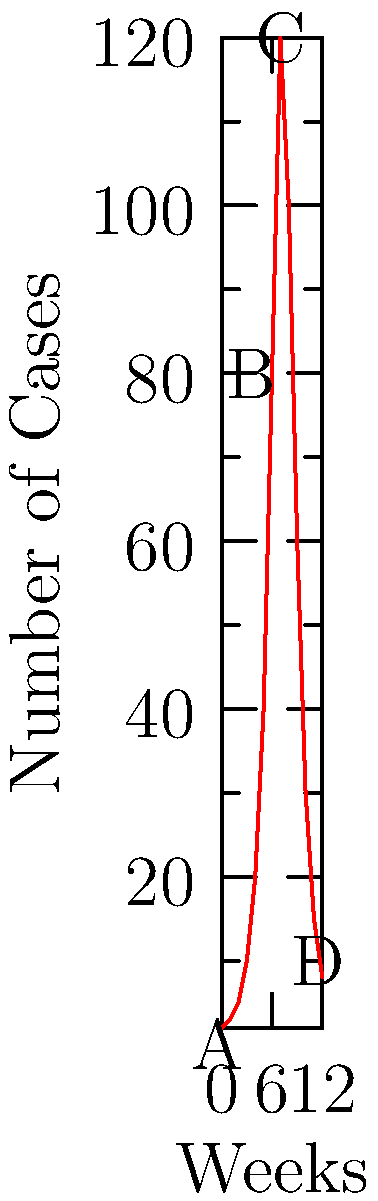Based on the epidemic curve shown, which phase of the outbreak is represented by the region labeled 'B'? To interpret this epidemic curve and identify outbreak phases, let's analyze each region:

1. Region A (Weeks 0-3):
   This represents the initial phase with a slow increase in cases, typical of the early stage of an outbreak.

2. Region B (Weeks 3-6):
   There's a rapid, exponential increase in cases. This is characteristic of the growth phase of an outbreak, where the pathogen spreads quickly through a susceptible population.

3. Region C (Weeks 6-8):
   The curve reaches its peak and plateaus briefly. This represents the peak of the outbreak.

4. Region D (Weeks 8-12):
   There's a decline in new cases, indicating the resolution phase of the outbreak.

The question asks specifically about region B. This region shows the steepest increase in cases over time, with the curve becoming nearly vertical. This pattern is indicative of the exponential growth phase of an outbreak, where each infected individual is infecting multiple others, leading to a rapid increase in case numbers.

In epidemiological terms, this is often referred to as the "exponential growth phase" or simply the "growth phase" of an outbreak.
Answer: Growth phase 